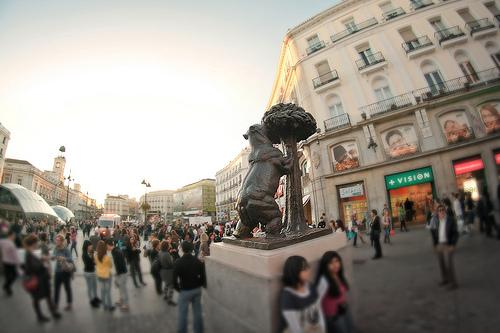Question: what does the green sign on the window says?
Choices:
A. Eye doctor.
B. Vision.
C. Sunglasses.
D. Eye glass repairs.
Answer with the letter. Answer: B Question: why are people gathered?
Choices:
A. There is a music concert.
B. An event taking place.
C. There is a graduation.
D. There is a wedding.
Answer with the letter. Answer: B Question: what color are the buildings?
Choices:
A. Cream.
B. Orange.
C. Blue.
D. Yellow.
Answer with the letter. Answer: A Question: where are everyone?
Choices:
A. In an open field.
B. In a courtyard.
C. In a park.
D. In a backyard.
Answer with the letter. Answer: B Question: what emergency vehicle is in the picture?
Choices:
A. A police car.
B. A fire truck.
C. A sheriff's car.
D. An ambulance.
Answer with the letter. Answer: D 